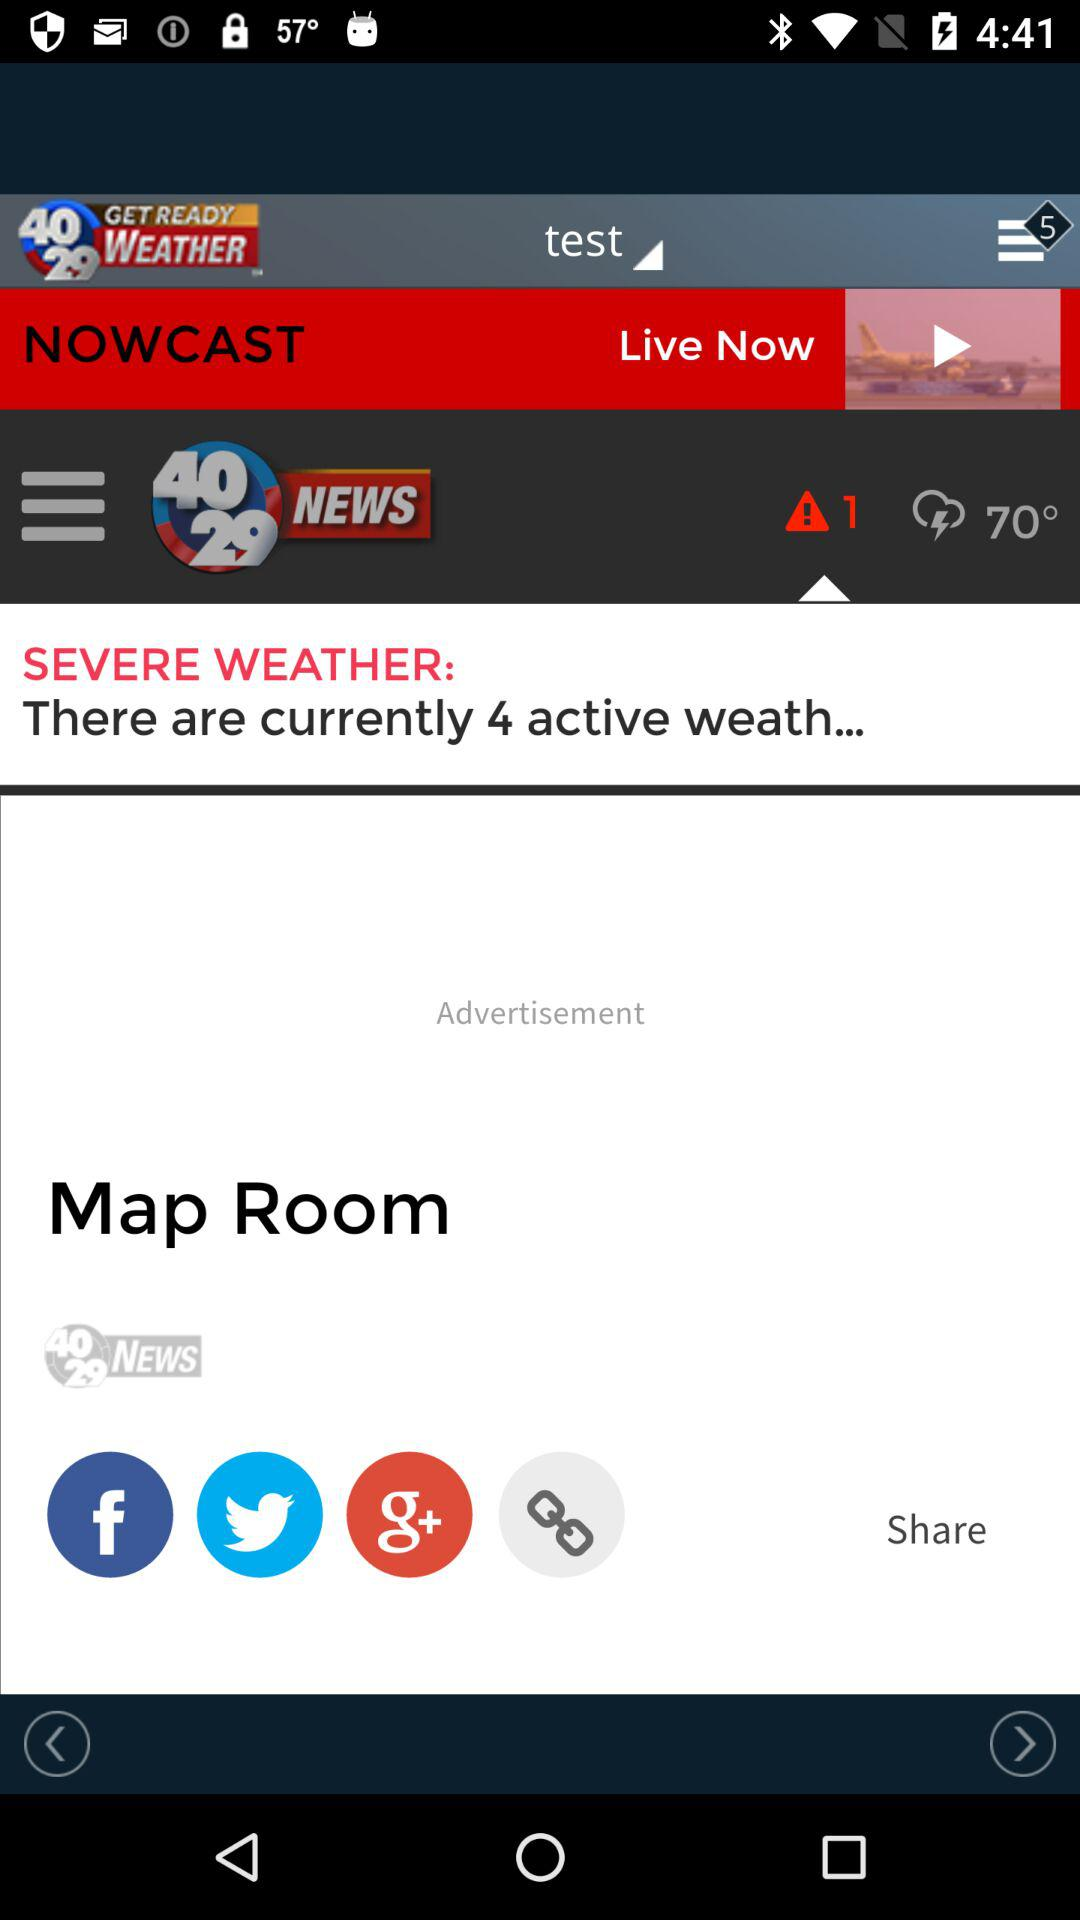How many notifications are pending in the menu? There are 5 pending notifications. 